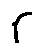<formula> <loc_0><loc_0><loc_500><loc_500>r</formula> 